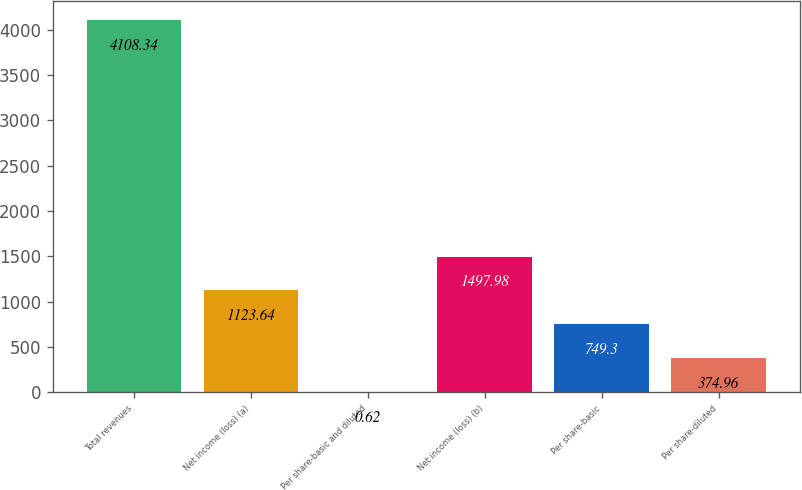<chart> <loc_0><loc_0><loc_500><loc_500><bar_chart><fcel>Total revenues<fcel>Net income (loss) (a)<fcel>Per share-basic and diluted<fcel>Net income (loss) (b)<fcel>Per share-basic<fcel>Per share-diluted<nl><fcel>4108.34<fcel>1123.64<fcel>0.62<fcel>1497.98<fcel>749.3<fcel>374.96<nl></chart> 